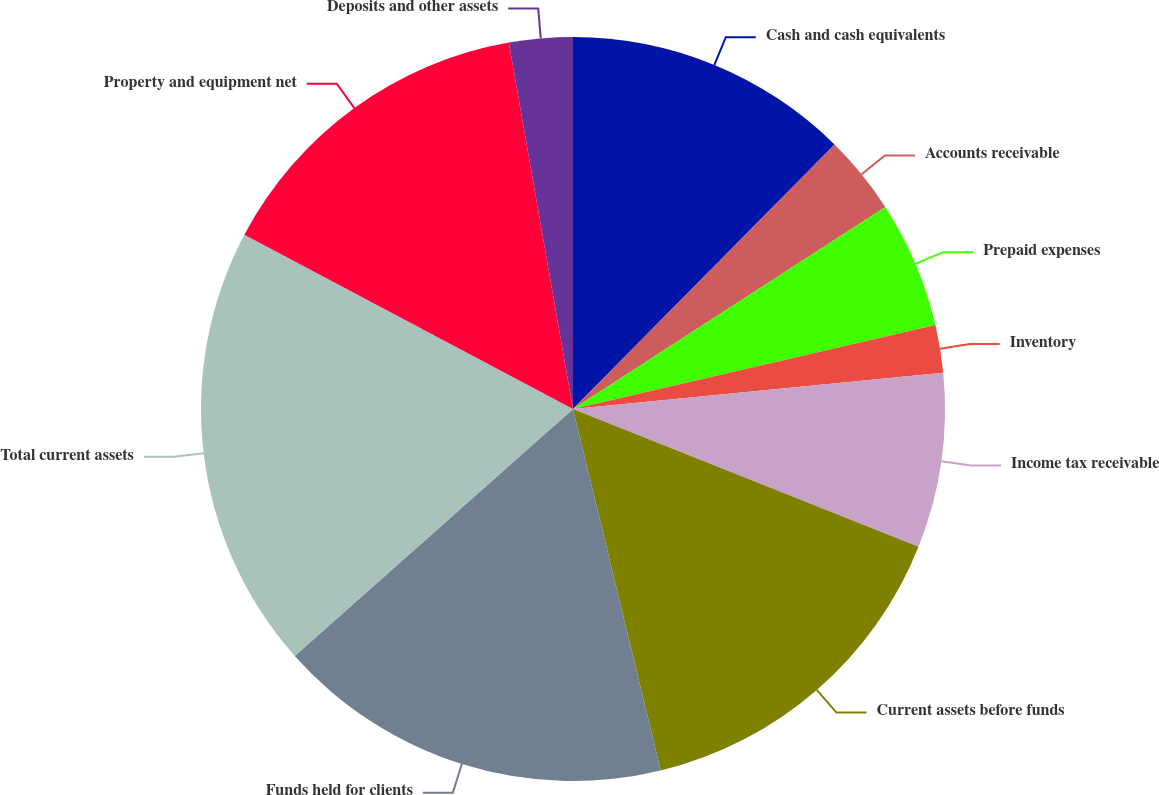Convert chart to OTSL. <chart><loc_0><loc_0><loc_500><loc_500><pie_chart><fcel>Cash and cash equivalents<fcel>Accounts receivable<fcel>Prepaid expenses<fcel>Inventory<fcel>Income tax receivable<fcel>Current assets before funds<fcel>Funds held for clients<fcel>Total current assets<fcel>Property and equipment net<fcel>Deposits and other assets<nl><fcel>12.41%<fcel>3.45%<fcel>5.52%<fcel>2.07%<fcel>7.59%<fcel>15.17%<fcel>17.24%<fcel>19.31%<fcel>14.48%<fcel>2.76%<nl></chart> 